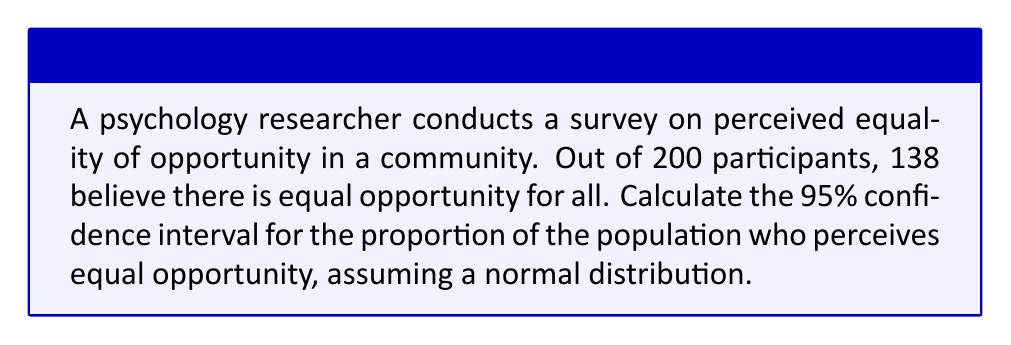Could you help me with this problem? To calculate the confidence interval, we'll follow these steps:

1. Calculate the sample proportion:
   $p = \frac{138}{200} = 0.69$

2. Calculate the standard error:
   $SE = \sqrt{\frac{p(1-p)}{n}} = \sqrt{\frac{0.69(1-0.69)}{200}} = 0.0327$

3. For a 95% confidence interval, use z-score of 1.96

4. Calculate the margin of error:
   $ME = 1.96 \times SE = 1.96 \times 0.0327 = 0.0641$

5. Calculate the confidence interval:
   Lower bound: $0.69 - 0.0641 = 0.6259$
   Upper bound: $0.69 + 0.0641 = 0.7541$

Therefore, the 95% confidence interval is (0.6259, 0.7541) or (62.59%, 75.41%).

This means we can be 95% confident that the true population proportion of those who perceive equal opportunity falls between 62.59% and 75.41%.
Answer: (0.6259, 0.7541) 